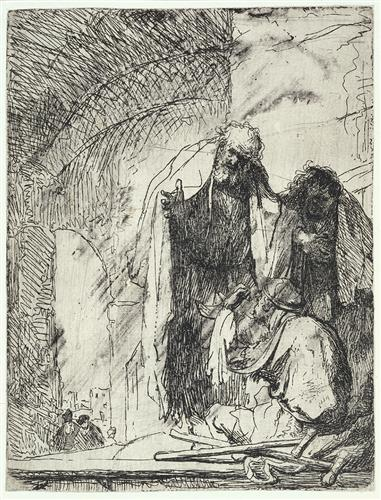What is this photo about? The etching presents a poignant depiction of what appears to be a biblical scene, potentially the mourning of a significant figure due to the somber expressions and the reverent postures of the robed individuals. The artist has skillfully used dramatic contrasts of light and shadow to convey a sense of depth and solemnity. Although reminiscent of Baroque techniques, the etching actually has a more expressive line work, akin to styles seen in etchings from different artistic movements. This particular piece invites contemplation not only of the scene it captures but also of the emotional resonance such imagery can evoke. 